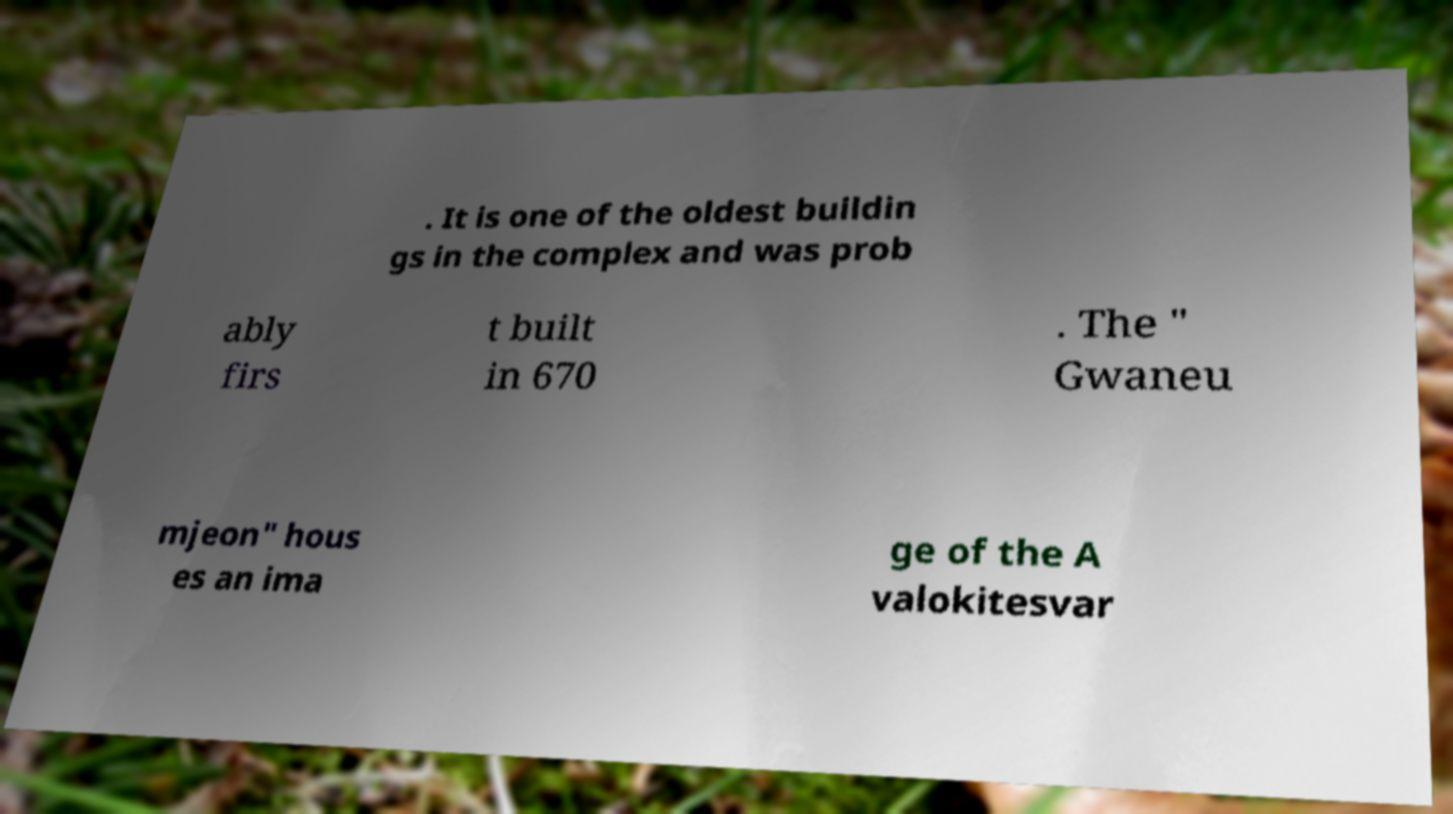For documentation purposes, I need the text within this image transcribed. Could you provide that? . It is one of the oldest buildin gs in the complex and was prob ably firs t built in 670 . The " Gwaneu mjeon" hous es an ima ge of the A valokitesvar 